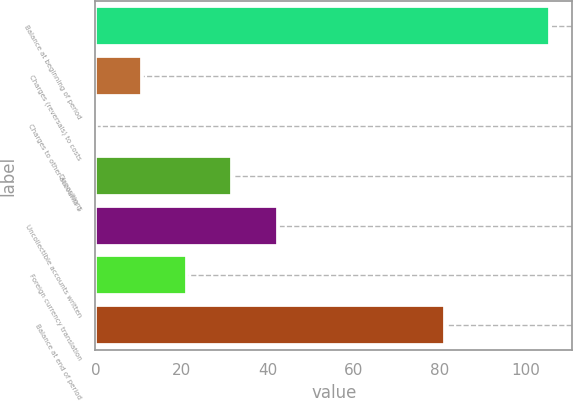Convert chart. <chart><loc_0><loc_0><loc_500><loc_500><bar_chart><fcel>Balance at beginning of period<fcel>Charges (reversals) to costs<fcel>Charges to other accounts 1<fcel>Dispositions<fcel>Uncollectible accounts written<fcel>Foreign currency translation<fcel>Balance at end of period<nl><fcel>105.5<fcel>10.73<fcel>0.2<fcel>31.79<fcel>42.32<fcel>21.26<fcel>81.3<nl></chart> 